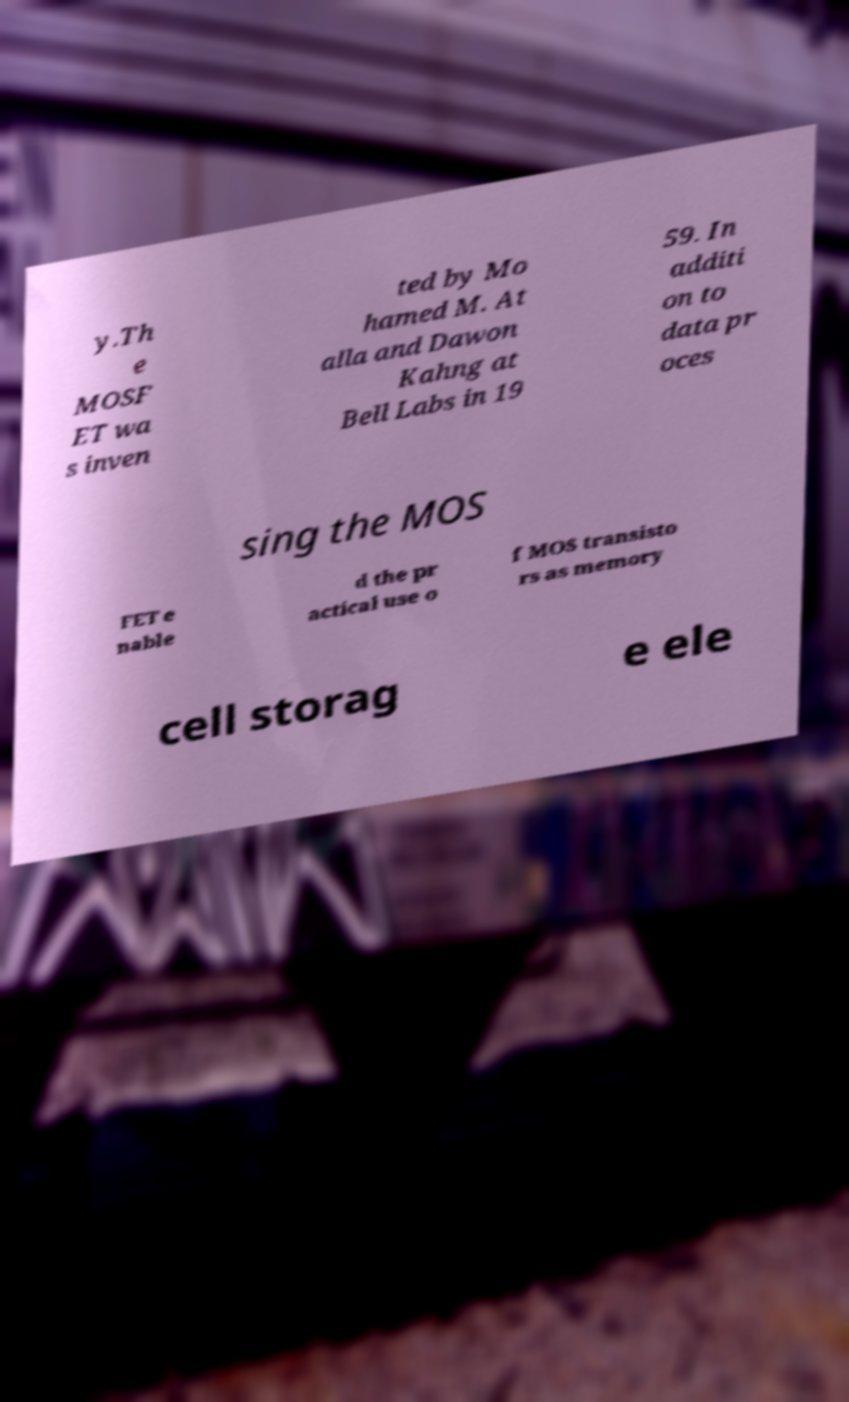Please identify and transcribe the text found in this image. y.Th e MOSF ET wa s inven ted by Mo hamed M. At alla and Dawon Kahng at Bell Labs in 19 59. In additi on to data pr oces sing the MOS FET e nable d the pr actical use o f MOS transisto rs as memory cell storag e ele 